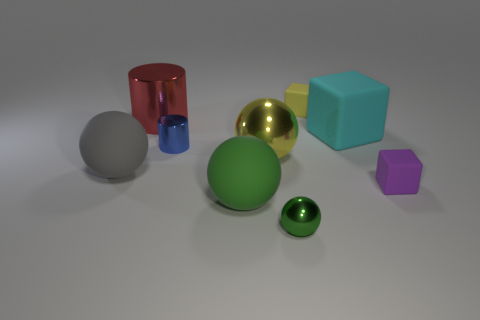Are there an equal number of large red things that are behind the red object and yellow metal balls?
Make the answer very short. No. What number of other things are there of the same color as the large cube?
Your answer should be very brief. 0. What is the color of the thing that is both behind the cyan cube and right of the red thing?
Keep it short and to the point. Yellow. What is the size of the yellow thing left of the shiny ball that is to the right of the yellow thing left of the small green metal ball?
Provide a short and direct response. Large. How many objects are either blocks that are in front of the yellow block or small rubber blocks that are behind the cyan block?
Keep it short and to the point. 3. What shape is the purple thing?
Ensure brevity in your answer.  Cube. How many other things are the same material as the purple cube?
Offer a terse response. 4. What is the size of the purple matte object that is the same shape as the cyan thing?
Your answer should be compact. Small. There is a large sphere that is on the right side of the big matte sphere that is in front of the small matte block that is in front of the large metal sphere; what is its material?
Ensure brevity in your answer.  Metal. Are any purple cubes visible?
Make the answer very short. Yes. 